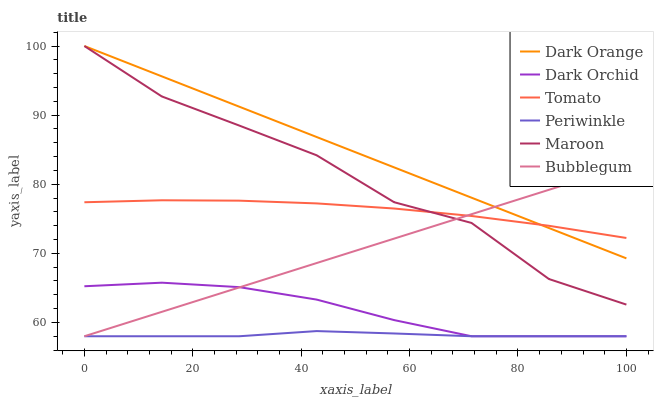Does Dark Orchid have the minimum area under the curve?
Answer yes or no. No. Does Dark Orchid have the maximum area under the curve?
Answer yes or no. No. Is Dark Orange the smoothest?
Answer yes or no. No. Is Dark Orange the roughest?
Answer yes or no. No. Does Dark Orange have the lowest value?
Answer yes or no. No. Does Dark Orchid have the highest value?
Answer yes or no. No. Is Periwinkle less than Tomato?
Answer yes or no. Yes. Is Tomato greater than Dark Orchid?
Answer yes or no. Yes. Does Periwinkle intersect Tomato?
Answer yes or no. No. 